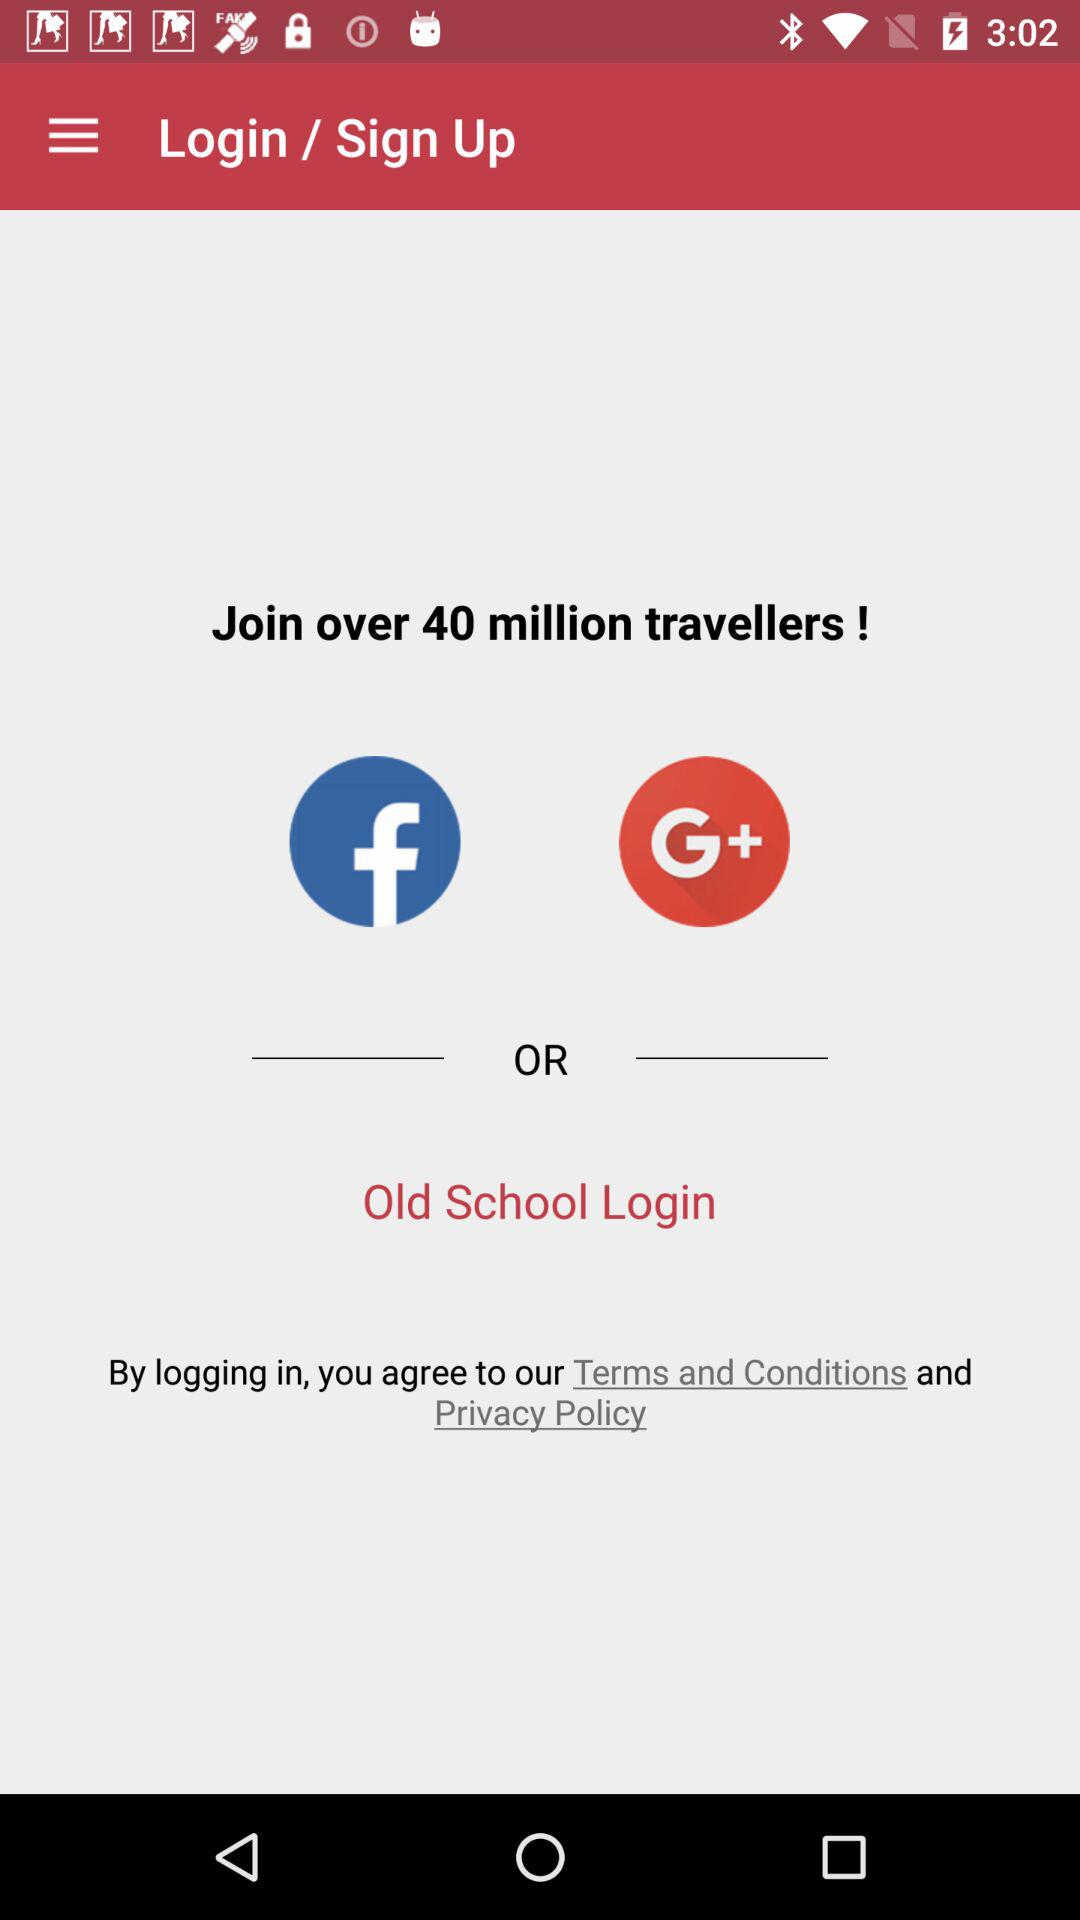Which are the different login options? The different login options are "Facebook", "Google+" and "Old School". 